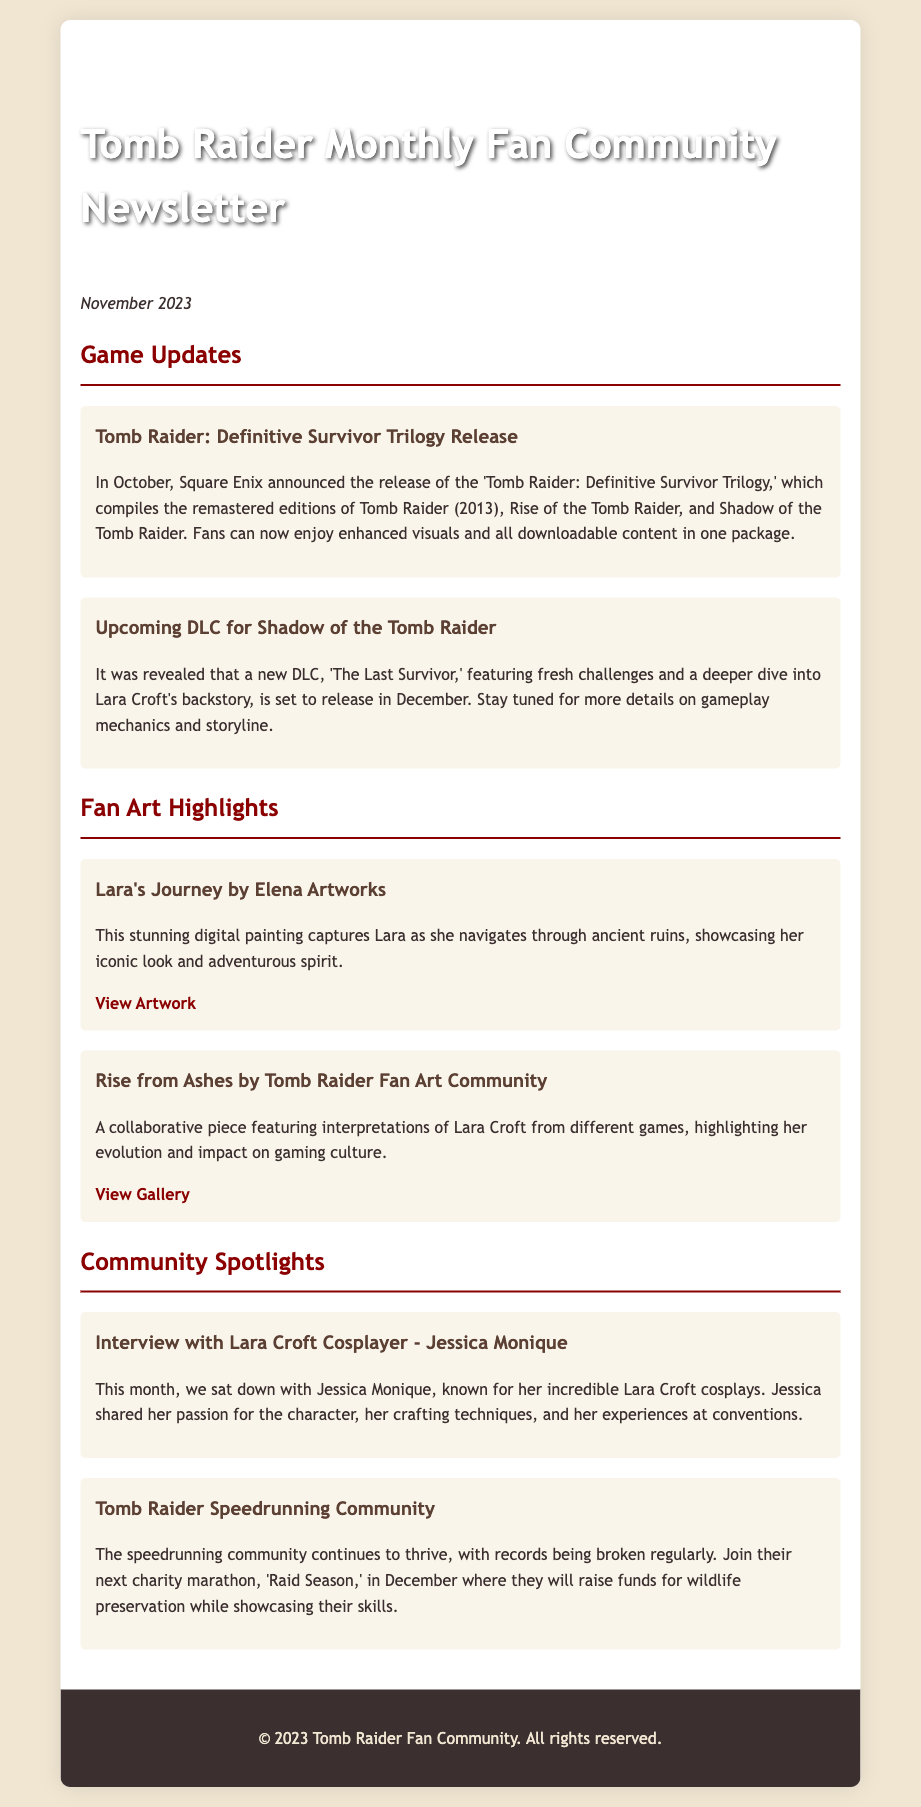What is the title of the newsletter? The title is mentioned at the top of the document.
Answer: Tomb Raider Monthly Fan Community Newsletter What month and year is this newsletter for? The date is specified at the beginning of the content.
Answer: November 2023 What is the name of the upcoming DLC for Shadow of the Tomb Raider? The DLC title is clearly stated in the game updates section.
Answer: The Last Survivor Who created the artwork titled "Lara's Journey"? The creator's name is stated in the fan art highlights section.
Answer: Elena Artworks What event is scheduled for December involving the speedrunning community? The event name is mentioned in the community spotlights section.
Answer: Raid Season How many games are included in the "Tomb Raider: Definitive Survivor Trilogy"? The total number of games is implied by the elements listed in the game updates.
Answer: Three What type of content does the "Tomb Raider: Definitive Survivor Trilogy" include? The type of content is outlined in the relevant game update.
Answer: Remastered editions Which platform is mentioned for viewing the "Rise from Ashes" artwork? The platform is specified in the fan art highlights.
Answer: DeviantArt What topic did Jessica Monique discuss in her interview? The main focus of the interview is highlighted in the community spotlight.
Answer: Cosplay 